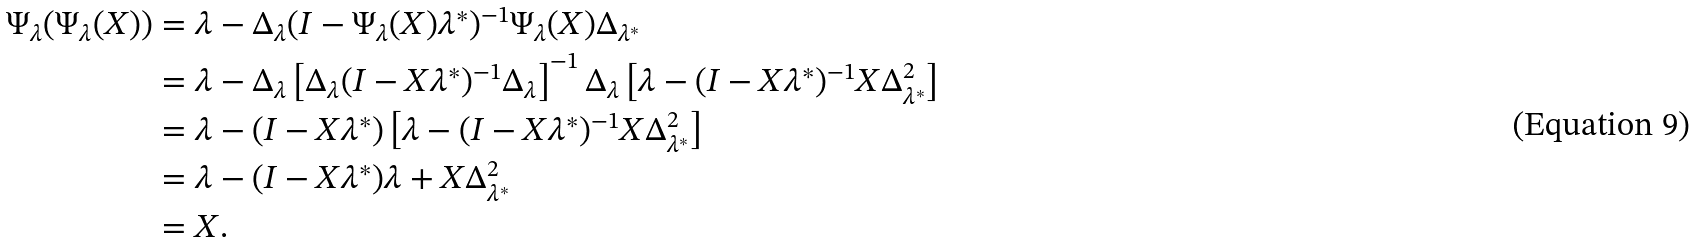<formula> <loc_0><loc_0><loc_500><loc_500>\Psi _ { \lambda } ( \Psi _ { \lambda } ( X ) ) & = \lambda - \Delta _ { \lambda } ( I - \Psi _ { \lambda } ( X ) \lambda ^ { * } ) ^ { - 1 } \Psi _ { \lambda } ( X ) \Delta _ { \lambda ^ { * } } \\ & = \lambda - \Delta _ { \lambda } \left [ \Delta _ { \lambda } ( I - X \lambda ^ { * } ) ^ { - 1 } \Delta _ { \lambda } \right ] ^ { - 1 } \Delta _ { \lambda } \left [ \lambda - ( I - X \lambda ^ { * } ) ^ { - 1 } X \Delta _ { \lambda ^ { * } } ^ { 2 } \right ] \\ & = \lambda - ( I - X \lambda ^ { * } ) \left [ \lambda - ( I - X \lambda ^ { * } ) ^ { - 1 } X \Delta _ { \lambda ^ { * } } ^ { 2 } \right ] \\ & = \lambda - ( I - X \lambda ^ { * } ) \lambda + X \Delta _ { \lambda ^ { * } } ^ { 2 } \\ & = X .</formula> 